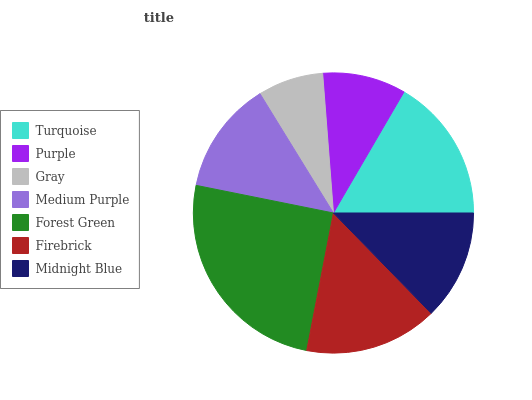Is Gray the minimum?
Answer yes or no. Yes. Is Forest Green the maximum?
Answer yes or no. Yes. Is Purple the minimum?
Answer yes or no. No. Is Purple the maximum?
Answer yes or no. No. Is Turquoise greater than Purple?
Answer yes or no. Yes. Is Purple less than Turquoise?
Answer yes or no. Yes. Is Purple greater than Turquoise?
Answer yes or no. No. Is Turquoise less than Purple?
Answer yes or no. No. Is Medium Purple the high median?
Answer yes or no. Yes. Is Medium Purple the low median?
Answer yes or no. Yes. Is Gray the high median?
Answer yes or no. No. Is Midnight Blue the low median?
Answer yes or no. No. 